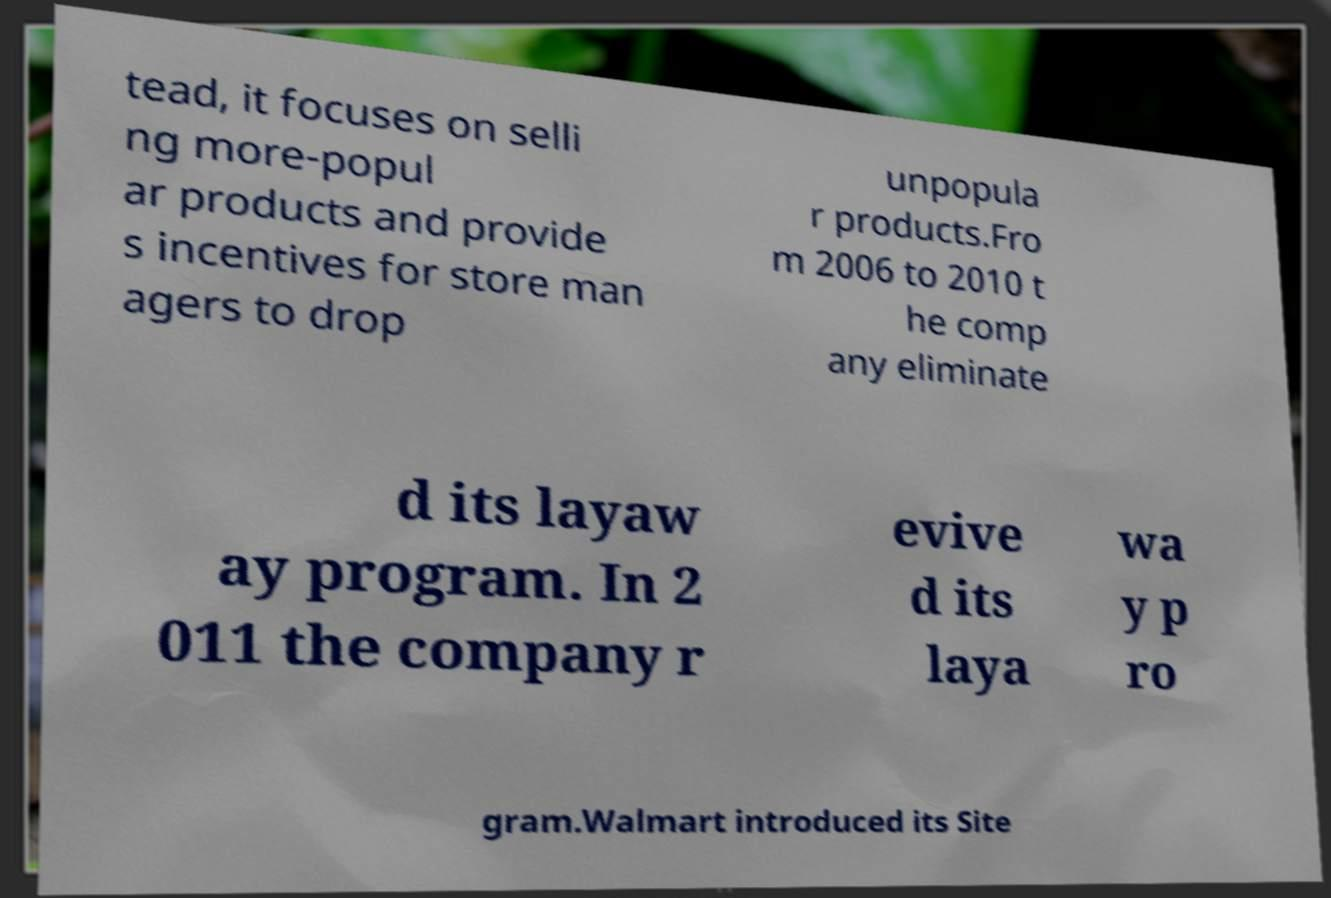There's text embedded in this image that I need extracted. Can you transcribe it verbatim? tead, it focuses on selli ng more-popul ar products and provide s incentives for store man agers to drop unpopula r products.Fro m 2006 to 2010 t he comp any eliminate d its layaw ay program. In 2 011 the company r evive d its laya wa y p ro gram.Walmart introduced its Site 